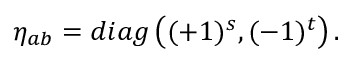<formula> <loc_0><loc_0><loc_500><loc_500>\eta _ { a b } = d i a g \left ( ( + 1 ) ^ { s } , ( - 1 ) ^ { t } \right ) .</formula> 